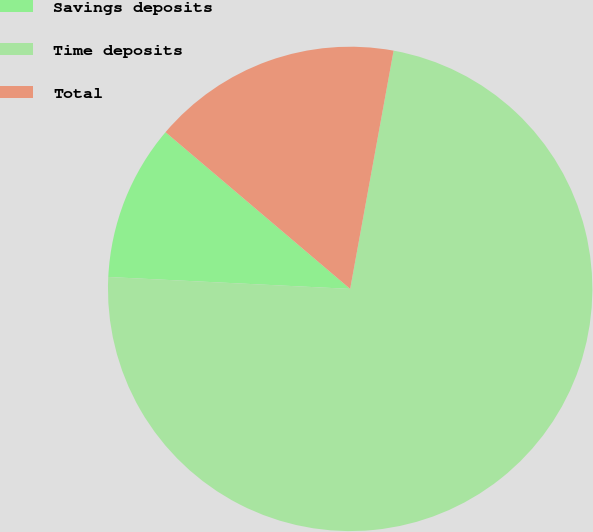<chart> <loc_0><loc_0><loc_500><loc_500><pie_chart><fcel>Savings deposits<fcel>Time deposits<fcel>Total<nl><fcel>10.42%<fcel>72.92%<fcel>16.67%<nl></chart> 